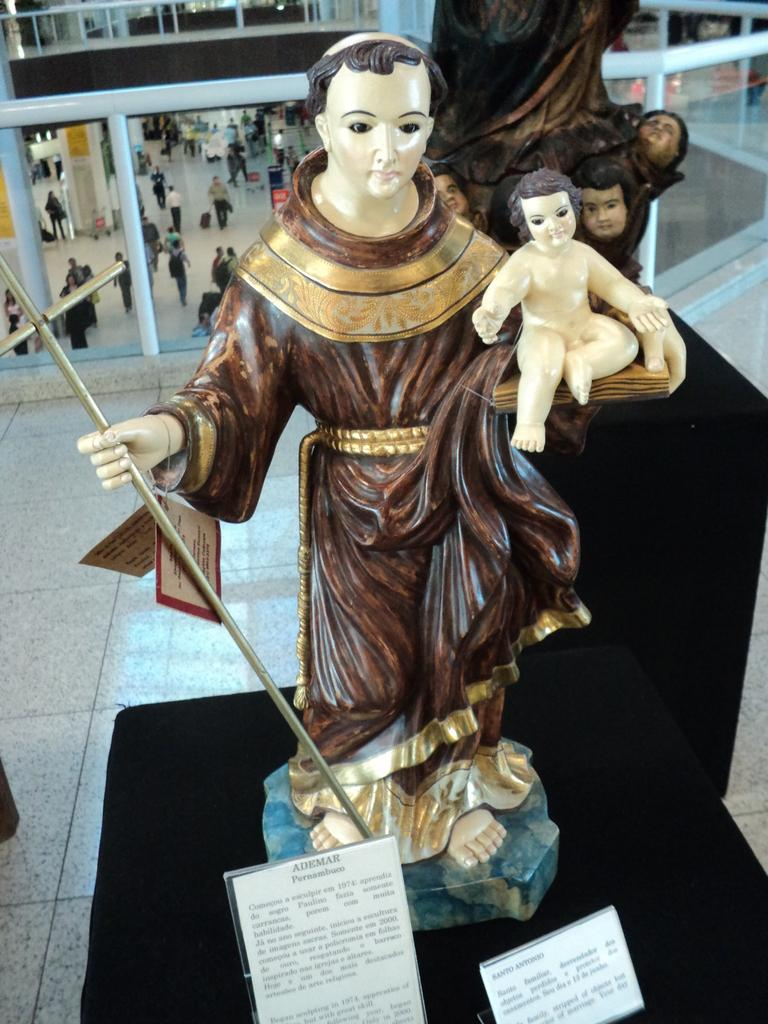What can be seen in the image besides the sculptures? The surface behind the sculptures is black, and there is a glass railing in the background of the image. What is happening behind the railing? People are walking on the floor behind the railing. What information can be gathered from the name boards on the sculptures? The name boards provide information about the sculptures, such as their names or artists. How does the juice compare to the sculptures in the image? There is no juice present in the image, so it cannot be compared to the sculptures. 